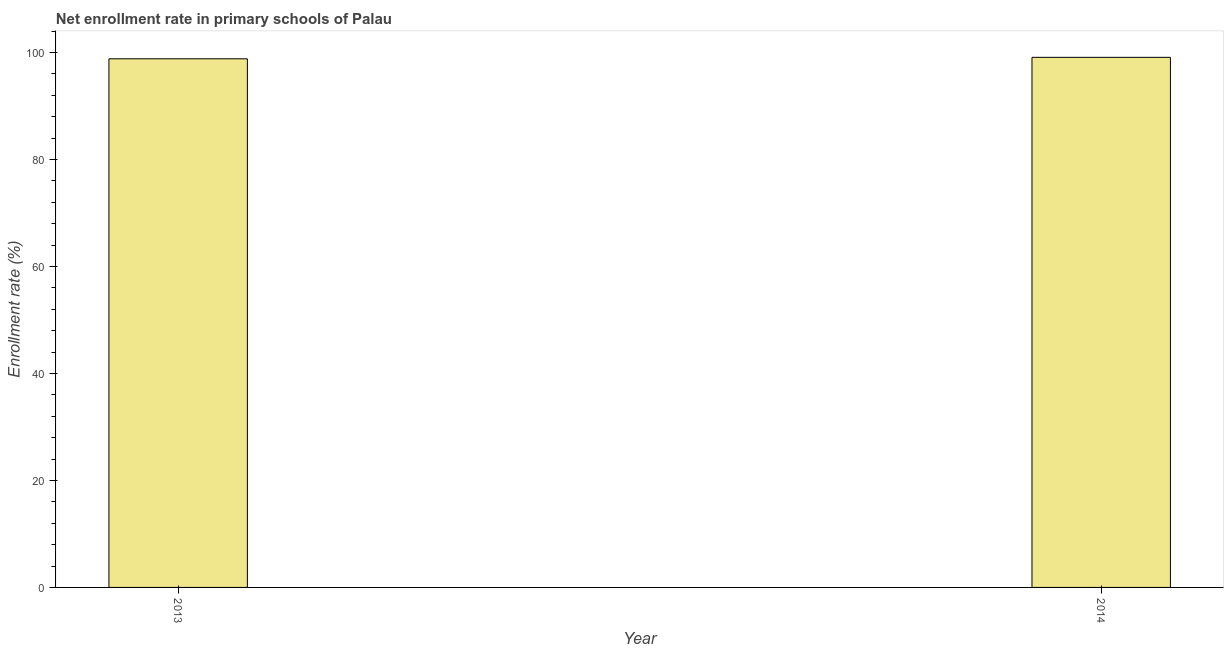Does the graph contain any zero values?
Provide a succinct answer. No. What is the title of the graph?
Your response must be concise. Net enrollment rate in primary schools of Palau. What is the label or title of the X-axis?
Keep it short and to the point. Year. What is the label or title of the Y-axis?
Provide a succinct answer. Enrollment rate (%). What is the net enrollment rate in primary schools in 2014?
Keep it short and to the point. 99.09. Across all years, what is the maximum net enrollment rate in primary schools?
Provide a short and direct response. 99.09. Across all years, what is the minimum net enrollment rate in primary schools?
Your answer should be very brief. 98.82. In which year was the net enrollment rate in primary schools maximum?
Your answer should be very brief. 2014. What is the sum of the net enrollment rate in primary schools?
Keep it short and to the point. 197.91. What is the difference between the net enrollment rate in primary schools in 2013 and 2014?
Your answer should be compact. -0.28. What is the average net enrollment rate in primary schools per year?
Give a very brief answer. 98.95. What is the median net enrollment rate in primary schools?
Provide a succinct answer. 98.96. What is the ratio of the net enrollment rate in primary schools in 2013 to that in 2014?
Keep it short and to the point. 1. In how many years, is the net enrollment rate in primary schools greater than the average net enrollment rate in primary schools taken over all years?
Your answer should be very brief. 1. How many bars are there?
Keep it short and to the point. 2. Are all the bars in the graph horizontal?
Offer a terse response. No. How many years are there in the graph?
Ensure brevity in your answer.  2. Are the values on the major ticks of Y-axis written in scientific E-notation?
Provide a short and direct response. No. What is the Enrollment rate (%) in 2013?
Offer a very short reply. 98.82. What is the Enrollment rate (%) in 2014?
Your answer should be compact. 99.09. What is the difference between the Enrollment rate (%) in 2013 and 2014?
Your answer should be compact. -0.28. 